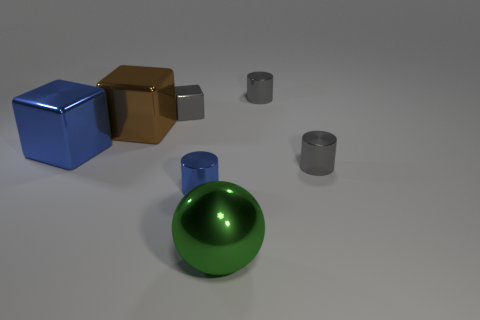How many gray metallic blocks have the same size as the brown shiny cube?
Your response must be concise. 0. The small cube that is the same material as the big green object is what color?
Your response must be concise. Gray. Is the number of tiny blue cylinders left of the tiny blue cylinder less than the number of small blue balls?
Your response must be concise. No. There is a blue object that is the same material as the blue cube; what shape is it?
Make the answer very short. Cylinder. What number of rubber objects are brown things or large green objects?
Make the answer very short. 0. Is the number of metallic spheres that are on the left side of the blue cylinder the same as the number of big green matte cubes?
Give a very brief answer. Yes. There is a cylinder behind the large blue metallic thing; is it the same color as the small block?
Provide a short and direct response. Yes. What is the material of the thing that is in front of the big brown metal thing and on the left side of the tiny blue object?
Offer a very short reply. Metal. There is a blue block that is behind the green metal thing; are there any large metal objects behind it?
Make the answer very short. Yes. Are the brown cube and the tiny gray block made of the same material?
Provide a short and direct response. Yes. 